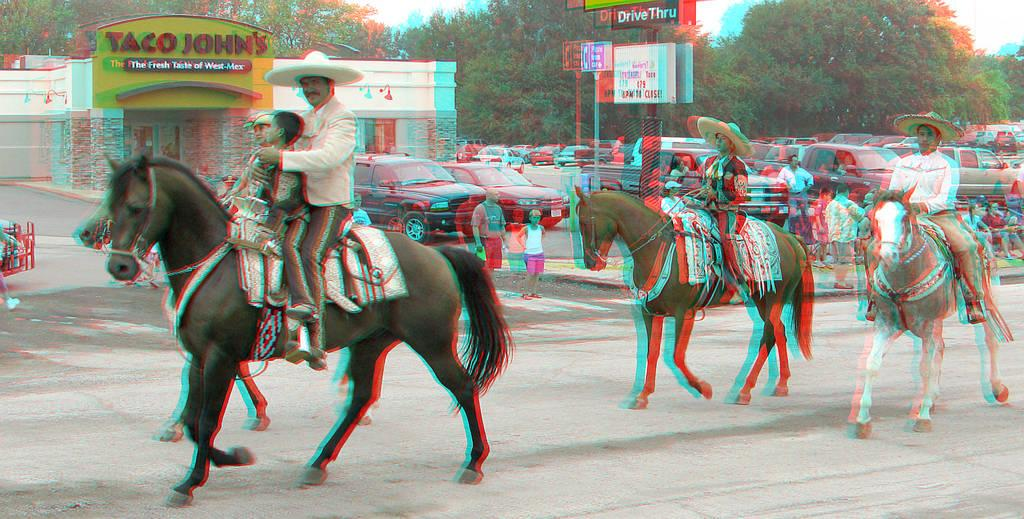What are the persons in the image doing? The persons are riding a horse in the image. What can be seen in the background of the image? There are cars and a building visible in the background of the image. What type of lumber is being used by the persons riding the horse? There is no lumber present in the image. The persons are riding a horse, and there is no indication of any lumber being used. 